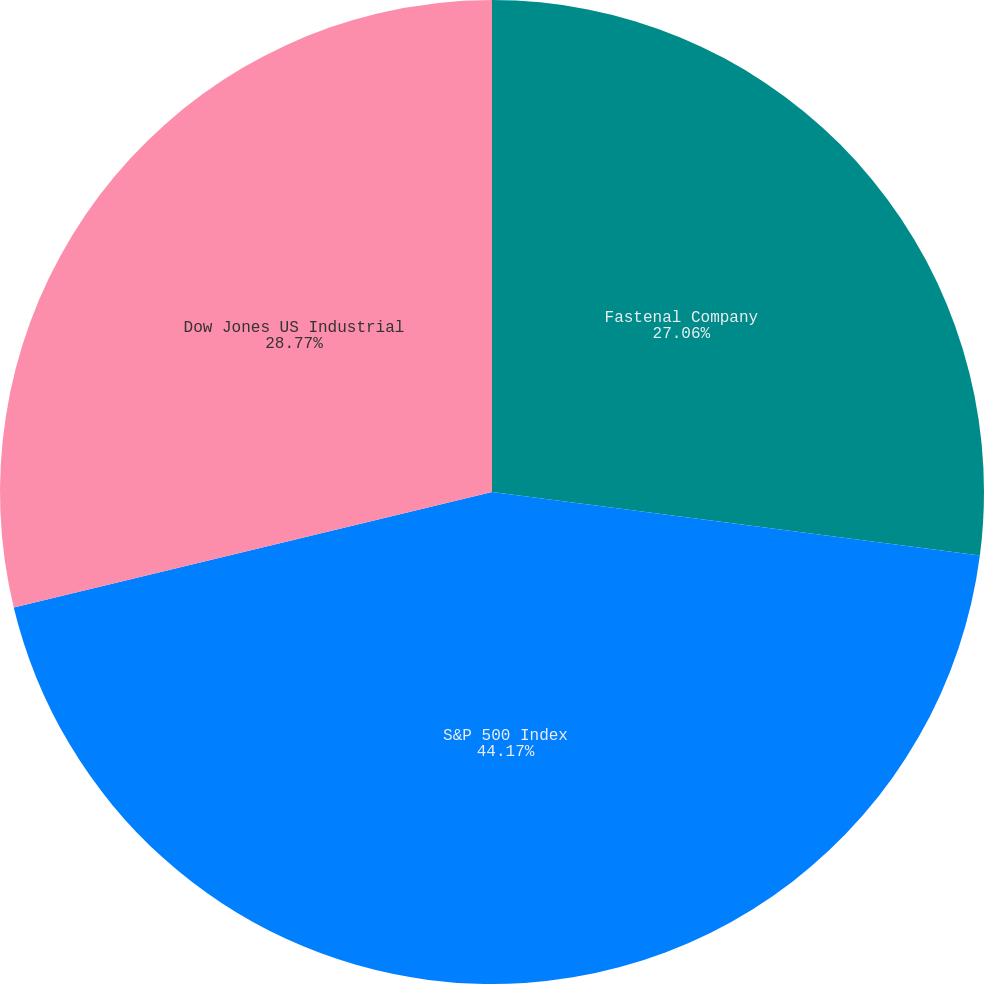Convert chart to OTSL. <chart><loc_0><loc_0><loc_500><loc_500><pie_chart><fcel>Fastenal Company<fcel>S&P 500 Index<fcel>Dow Jones US Industrial<nl><fcel>27.06%<fcel>44.17%<fcel>28.77%<nl></chart> 